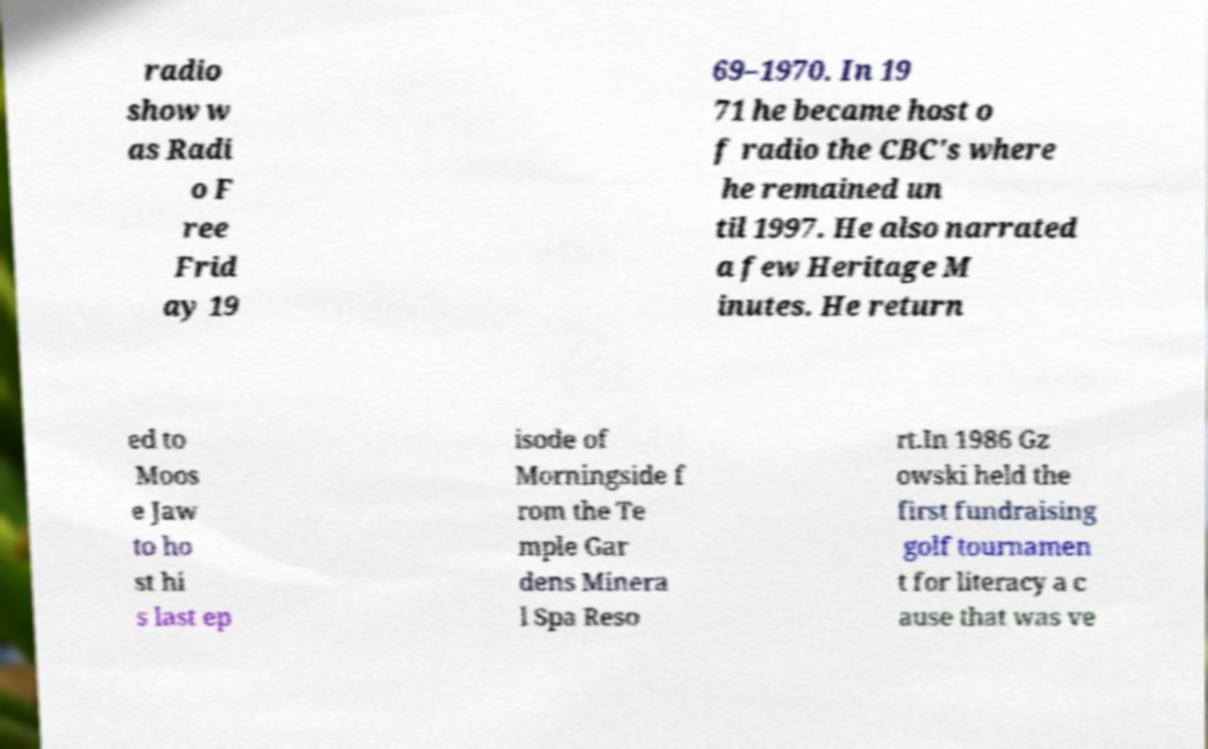I need the written content from this picture converted into text. Can you do that? radio show w as Radi o F ree Frid ay 19 69–1970. In 19 71 he became host o f radio the CBC's where he remained un til 1997. He also narrated a few Heritage M inutes. He return ed to Moos e Jaw to ho st hi s last ep isode of Morningside f rom the Te mple Gar dens Minera l Spa Reso rt.In 1986 Gz owski held the first fundraising golf tournamen t for literacy a c ause that was ve 